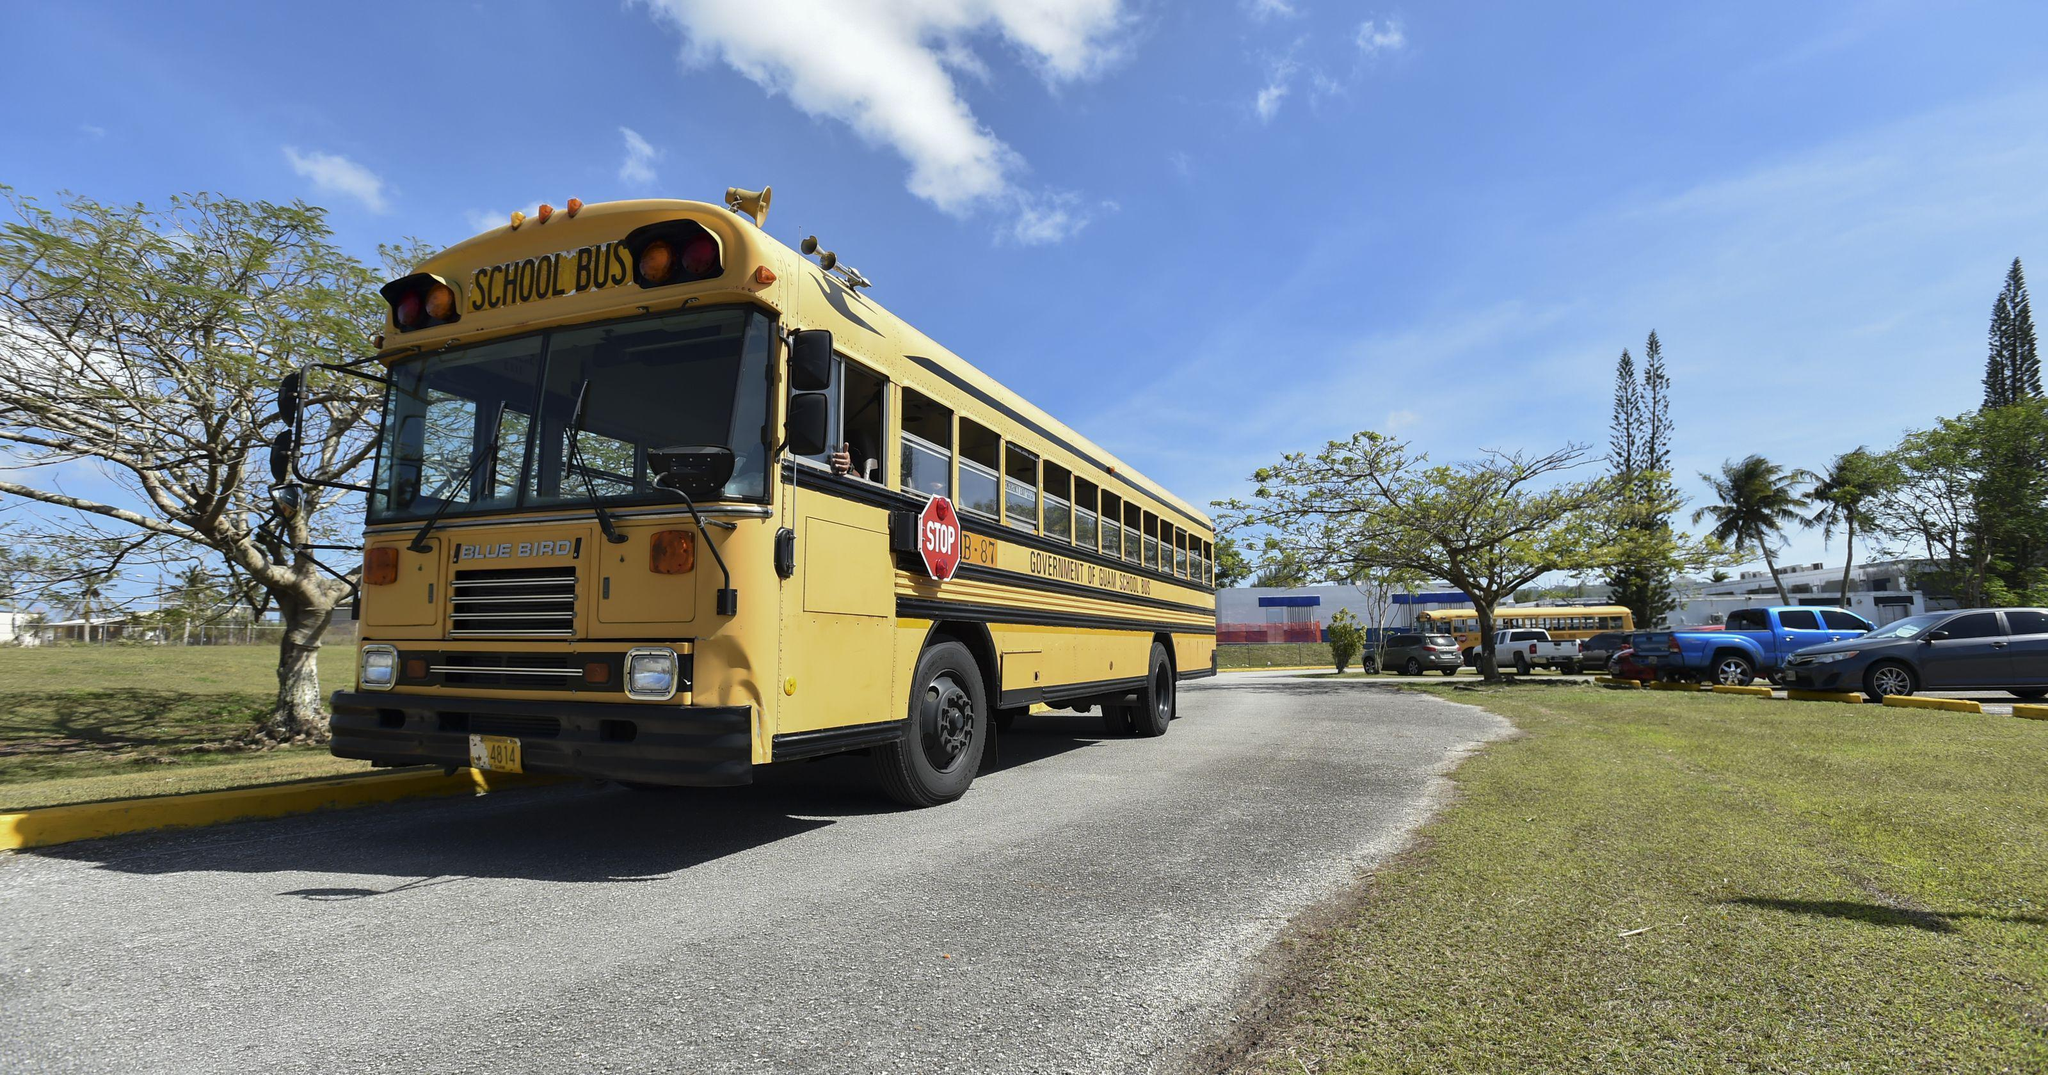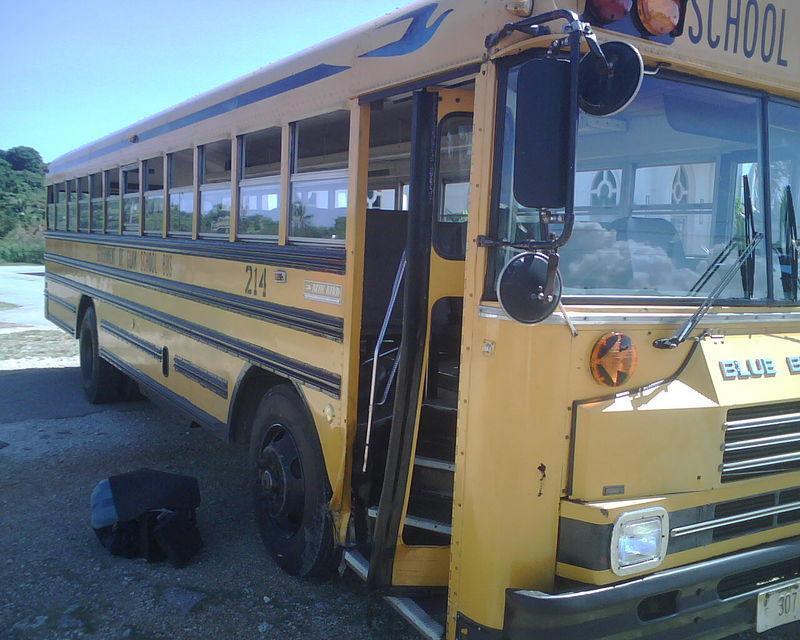The first image is the image on the left, the second image is the image on the right. For the images shown, is this caption "The right image contains at least three school buses." true? Answer yes or no. No. The first image is the image on the left, the second image is the image on the right. For the images displayed, is the sentence "The door of the bus in the image on the right is open." factually correct? Answer yes or no. Yes. 